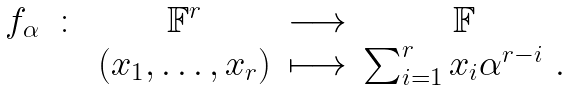<formula> <loc_0><loc_0><loc_500><loc_500>\begin{array} { c c c c c } f _ { \alpha } & \colon & \mathbb { F } ^ { r } & \longrightarrow & \mathbb { F } \\ & & ( x _ { 1 } , \dots , x _ { r } ) & \longmapsto & \sum _ { i = 1 } ^ { r } x _ { i } \alpha ^ { r - i } \ . \end{array}</formula> 